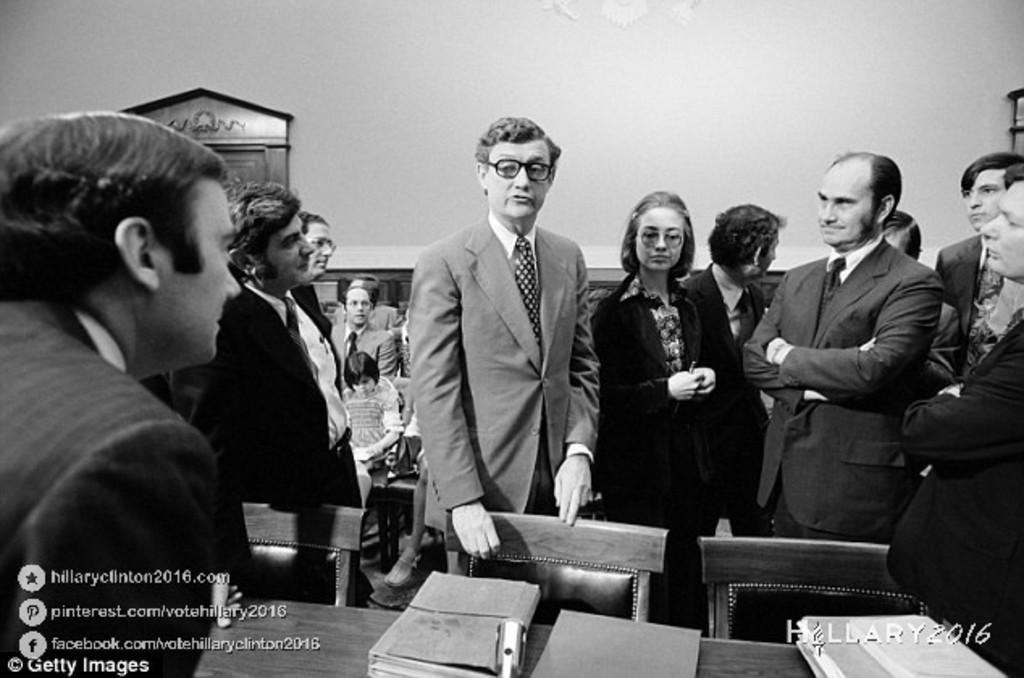What is happening in the image? There are people standing in the image. What objects can be seen on the table in the image? There are books on a table in the image. Where is text located in the image? There is text in the bottom left and bottom right corners of the image. How many fish can be seen swimming in the image? There are no fish present in the image. What type of insect is crawling on the table in the image? There are no insects present in the image. 